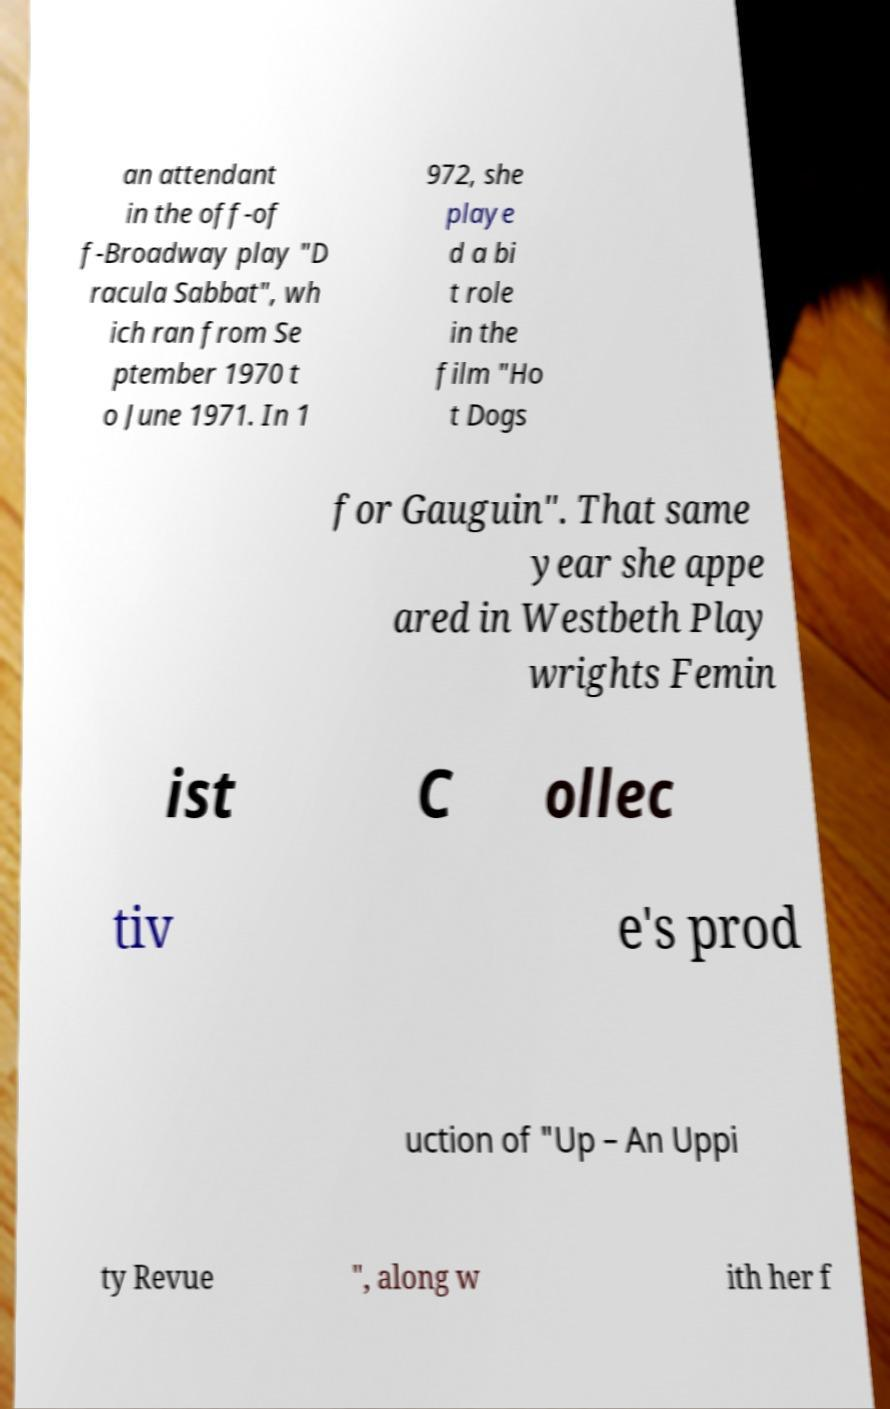Can you accurately transcribe the text from the provided image for me? an attendant in the off-of f-Broadway play "D racula Sabbat", wh ich ran from Se ptember 1970 t o June 1971. In 1 972, she playe d a bi t role in the film "Ho t Dogs for Gauguin". That same year she appe ared in Westbeth Play wrights Femin ist C ollec tiv e's prod uction of "Up – An Uppi ty Revue ", along w ith her f 